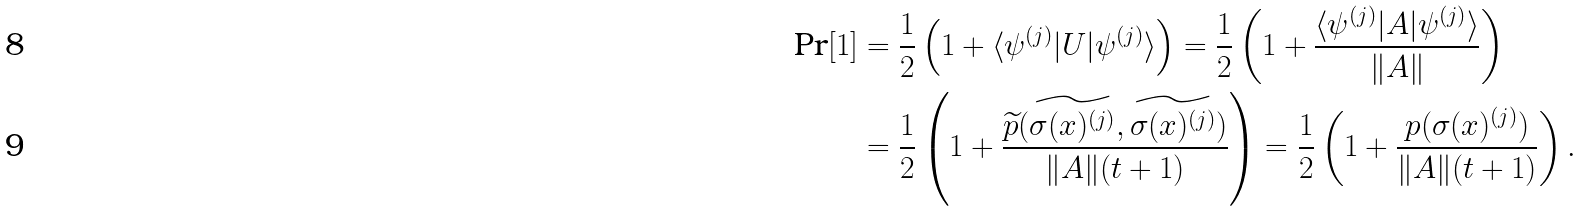<formula> <loc_0><loc_0><loc_500><loc_500>\text {Pr} [ 1 ] & = \frac { 1 } { 2 } \left ( 1 + \langle \psi ^ { ( j ) } | U | \psi ^ { ( j ) } \rangle \right ) = \frac { 1 } { 2 } \left ( 1 + \frac { \langle \psi ^ { ( j ) } | A | \psi ^ { ( j ) } \rangle } { \| A \| } \right ) \\ & = \frac { 1 } { 2 } \left ( 1 + \frac { \widetilde { p } ( \widetilde { \sigma ( x ) ^ { ( j ) } } , \widetilde { \sigma ( x ) ^ { ( j ) } } ) } { \| A \| ( t + 1 ) } \right ) = \frac { 1 } { 2 } \left ( 1 + \frac { p ( \sigma ( x ) ^ { ( j ) } ) } { \| A \| ( t + 1 ) } \right ) .</formula> 